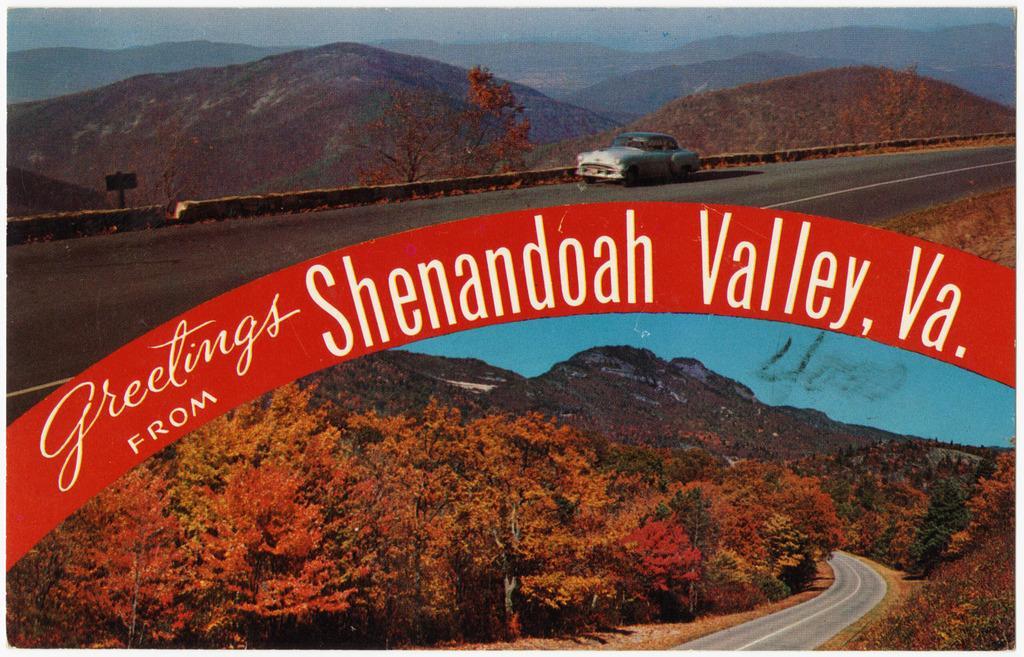Can you describe this image briefly? In this image I can see two collage photos where I can see number of trees, mountains, roads and the sky. On the top side of this image I can see a car on the road and in the centre I can see something is written. 